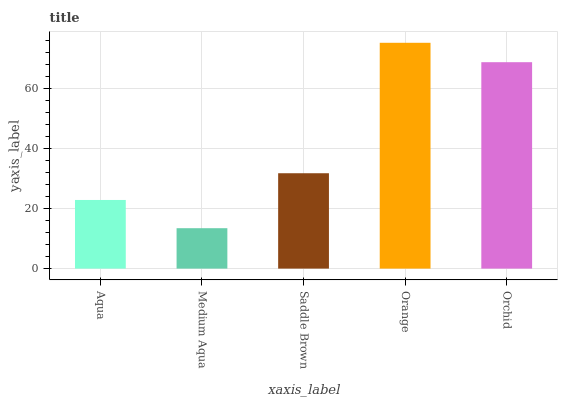Is Medium Aqua the minimum?
Answer yes or no. Yes. Is Orange the maximum?
Answer yes or no. Yes. Is Saddle Brown the minimum?
Answer yes or no. No. Is Saddle Brown the maximum?
Answer yes or no. No. Is Saddle Brown greater than Medium Aqua?
Answer yes or no. Yes. Is Medium Aqua less than Saddle Brown?
Answer yes or no. Yes. Is Medium Aqua greater than Saddle Brown?
Answer yes or no. No. Is Saddle Brown less than Medium Aqua?
Answer yes or no. No. Is Saddle Brown the high median?
Answer yes or no. Yes. Is Saddle Brown the low median?
Answer yes or no. Yes. Is Orchid the high median?
Answer yes or no. No. Is Medium Aqua the low median?
Answer yes or no. No. 